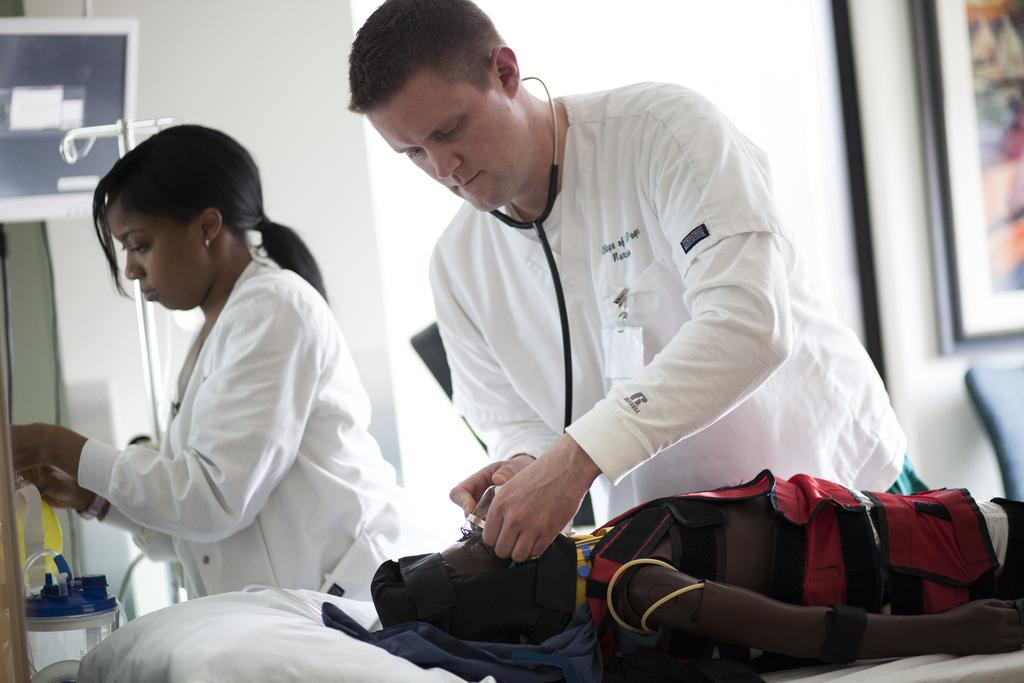How many people are present in the image? There are three people in the image. What are the positions of the people in the image? One person is lying on a bed, and two people are standing. What medical instrument can be seen in the image? There is a stethoscope in the image. What is hanging on the wall in the image? There is a frame on the wall. Can you tell me how high the kite is flying in the image? There is no kite present in the image, so it is not possible to determine its height. 